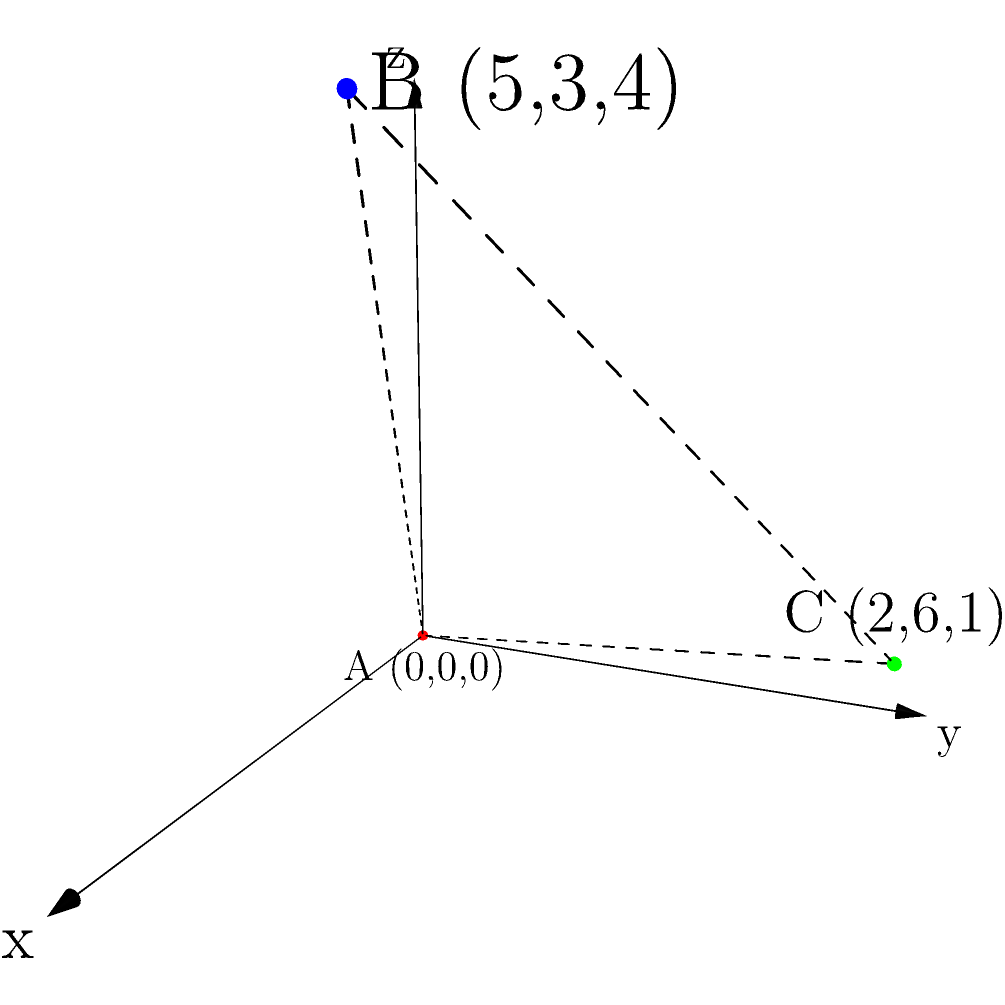A drone delivery system needs to transport packages between three points: A (0,0,0), B (5,3,4), and C (2,6,1). The drone can only fly in straight lines between these points. What is the shortest total distance the drone must fly to visit all three points exactly once and return to its starting point? To solve this problem, we need to calculate the distances between all pairs of points and determine the shortest path that visits all points once and returns to the starting point. Let's break it down step-by-step:

1. Calculate the distances between each pair of points using the 3D distance formula:
   $d = \sqrt{(x_2-x_1)^2 + (y_2-y_1)^2 + (z_2-z_1)^2}$

   AB: $\sqrt{(5-0)^2 + (3-0)^2 + (4-0)^2} = \sqrt{25 + 9 + 16} = \sqrt{50} = 5\sqrt{2}$
   AC: $\sqrt{(2-0)^2 + (6-0)^2 + (1-0)^2} = \sqrt{4 + 36 + 1} = \sqrt{41}$
   BC: $\sqrt{(2-5)^2 + (6-3)^2 + (1-4)^2} = \sqrt{9 + 9 + 9} = 3\sqrt{3}$

2. There are three possible paths to visit all points and return to the start:
   A-B-C-A, A-C-B-A, and B-C-A-B (which is equivalent to A-B-C-A)

3. Calculate the total distance for each path:
   A-B-C-A: $5\sqrt{2} + 3\sqrt{3} + \sqrt{41}$
   A-C-B-A: $\sqrt{41} + 3\sqrt{3} + 5\sqrt{2}$

4. Both paths have the same total distance, so either one is optimal.

5. The shortest total distance is:
   $5\sqrt{2} + 3\sqrt{3} + \sqrt{41}$

This solution ensures the drone visits all points once and returns to its starting point while minimizing the total distance traveled.
Answer: $5\sqrt{2} + 3\sqrt{3} + \sqrt{41}$ 